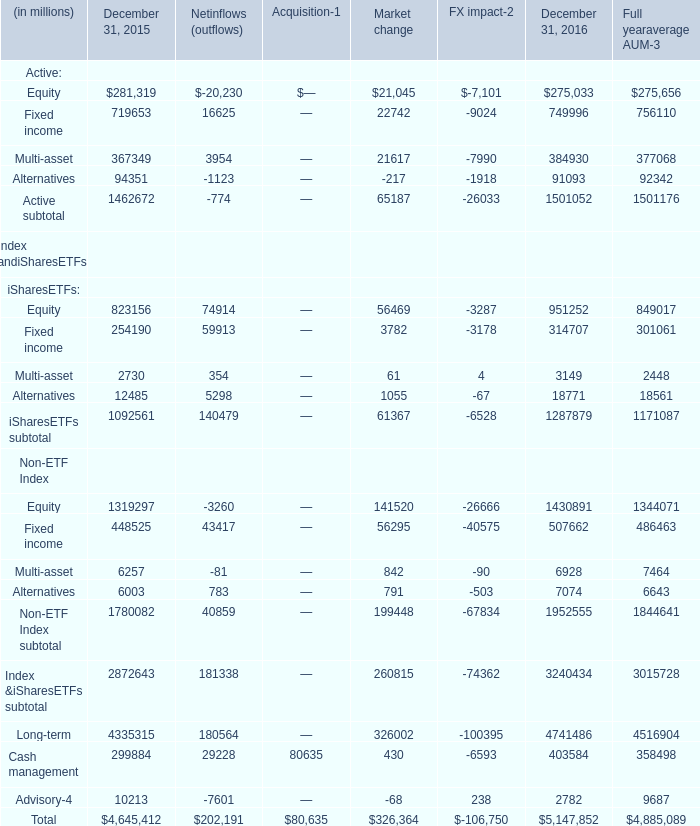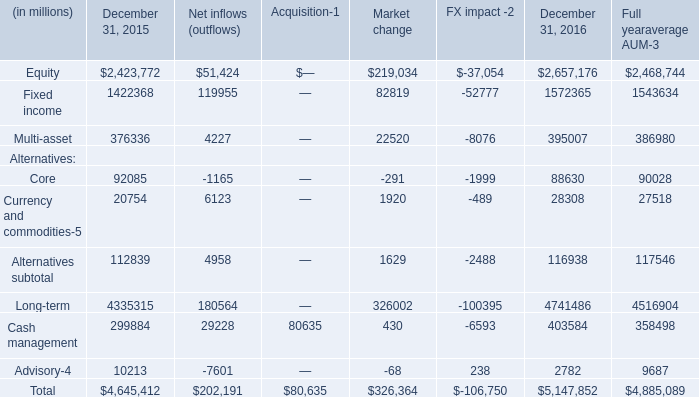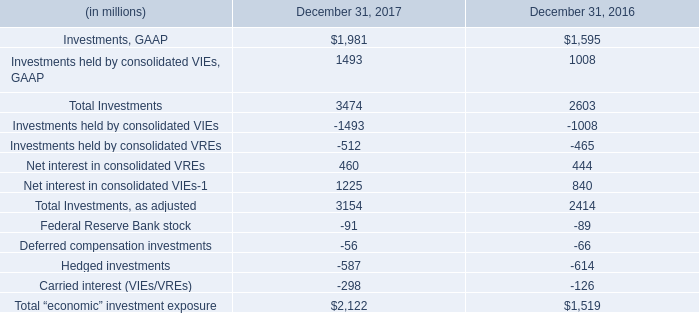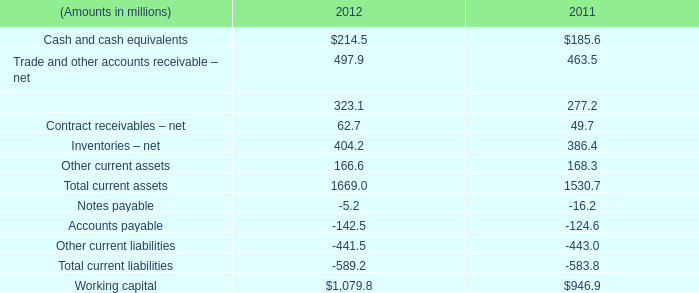What's the total amount of Active Market change excluding those negative ones in 2016? (in million) 
Computations: ((21045 + 22742) + 21617)
Answer: 65404.0. 